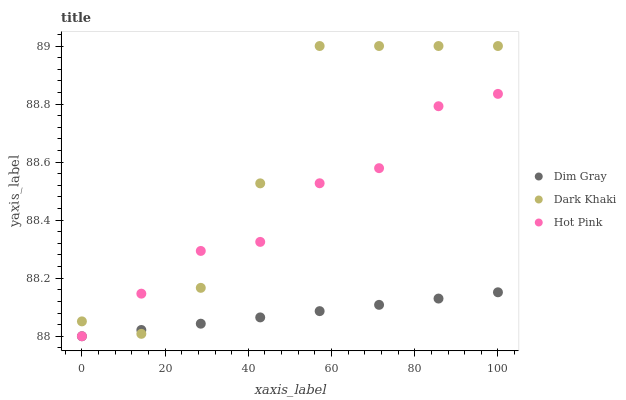Does Dim Gray have the minimum area under the curve?
Answer yes or no. Yes. Does Dark Khaki have the maximum area under the curve?
Answer yes or no. Yes. Does Hot Pink have the minimum area under the curve?
Answer yes or no. No. Does Hot Pink have the maximum area under the curve?
Answer yes or no. No. Is Dim Gray the smoothest?
Answer yes or no. Yes. Is Dark Khaki the roughest?
Answer yes or no. Yes. Is Hot Pink the smoothest?
Answer yes or no. No. Is Hot Pink the roughest?
Answer yes or no. No. Does Dim Gray have the lowest value?
Answer yes or no. Yes. Does Dark Khaki have the highest value?
Answer yes or no. Yes. Does Hot Pink have the highest value?
Answer yes or no. No. Does Dark Khaki intersect Dim Gray?
Answer yes or no. Yes. Is Dark Khaki less than Dim Gray?
Answer yes or no. No. Is Dark Khaki greater than Dim Gray?
Answer yes or no. No. 